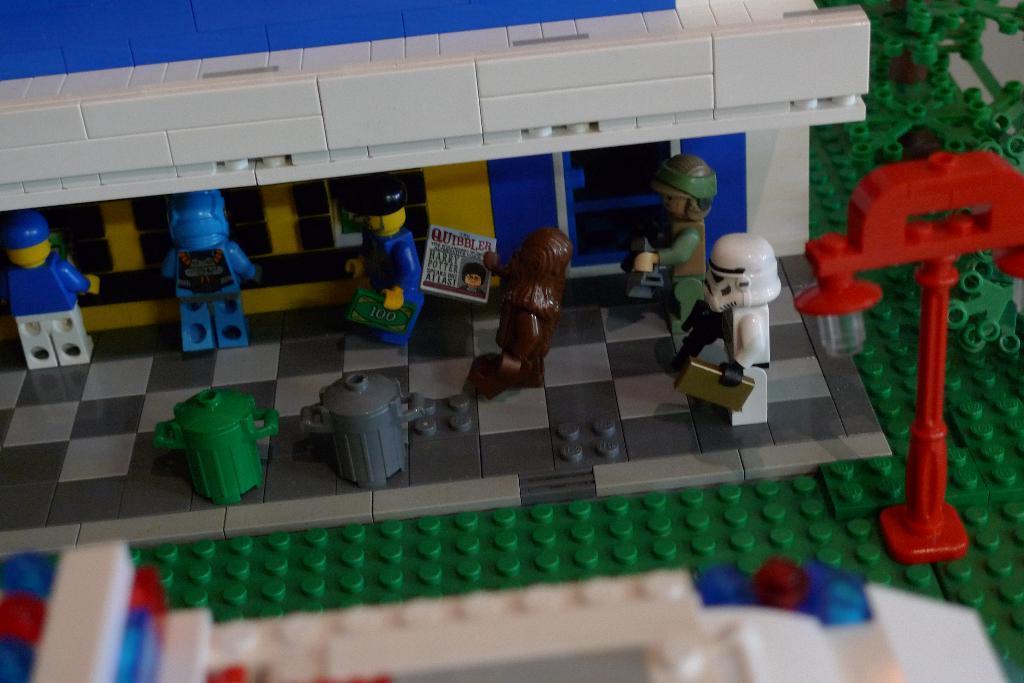How would you summarize this image in a sentence or two? In this image we can see building blocks, toys and this part of the image is slightly blurred. 